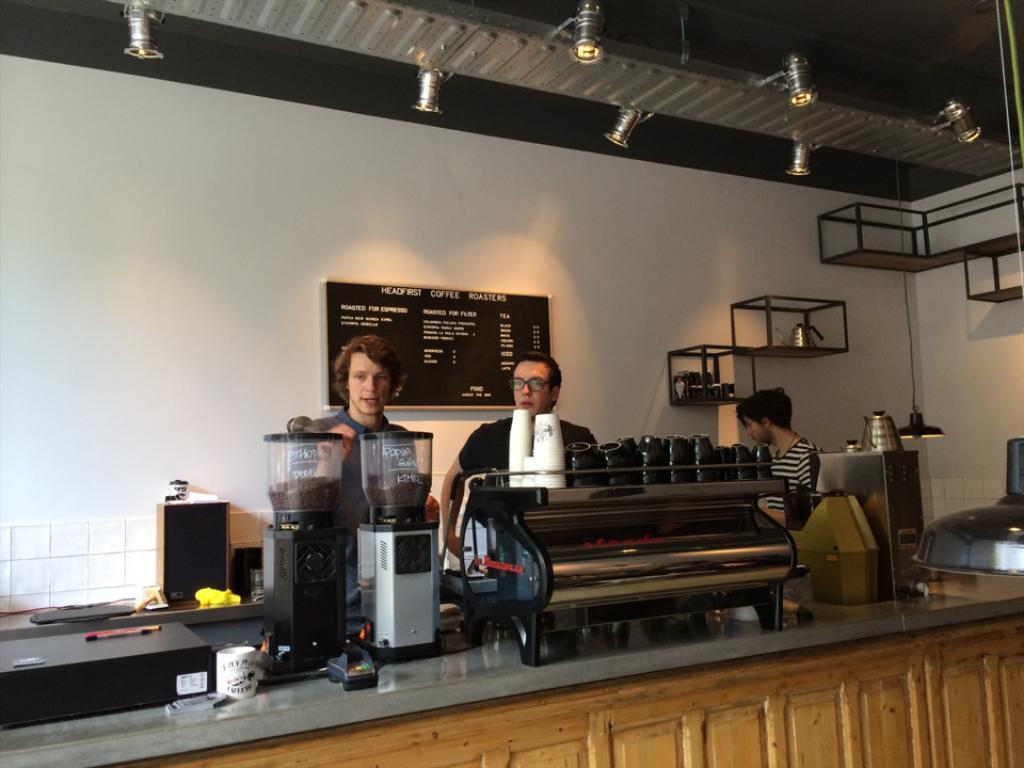<image>
Share a concise interpretation of the image provided. Three people work behind a counter with a sign behind them reading Headfirst Coffee Roasters. 